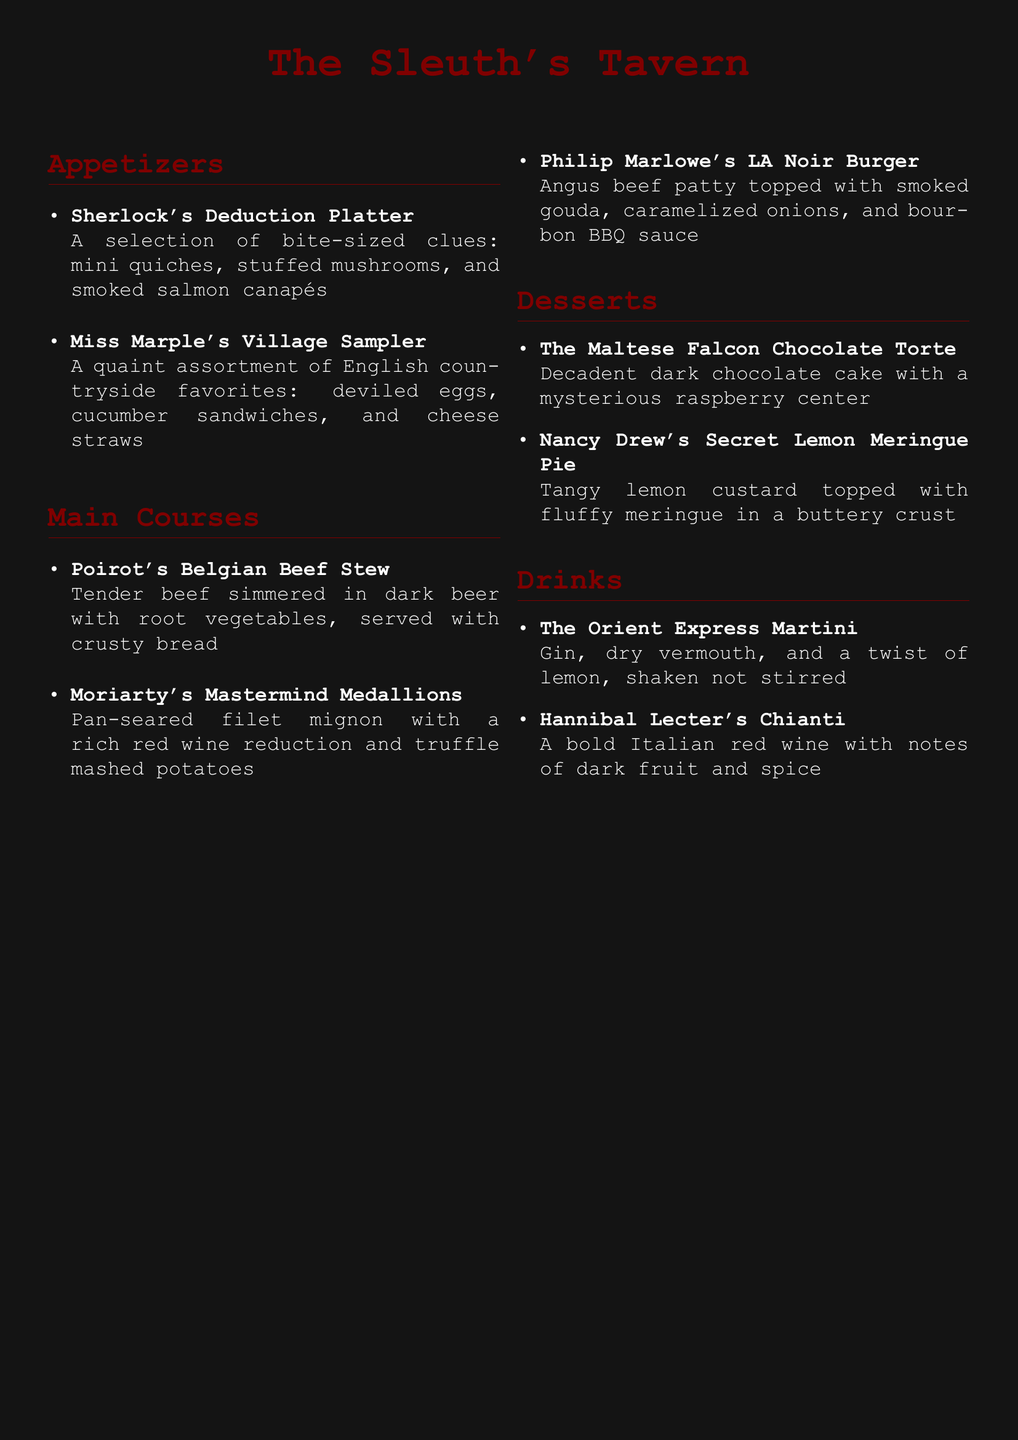What is the name of the appetizer platter? The name of the appetizer platter is found in the Appetizers section, which lists the offerings, including "Sherlock's Deduction Platter."
Answer: Sherlock's Deduction Platter How many main courses are listed on the menu? The total number of main courses can be determined by counting the items in the Main Courses section. There are four items listed.
Answer: 4 What type of burger does Philip Marlowe's dish refer to? The dish refers to a specific style of burger mentioned in the Main Courses section. It is described as an "LA Noir Burger."
Answer: LA Noir Burger What is the primary flavor note of Hannibal Lecter's drink? The primary flavor note of the drink can be found in the Drinks section where it describes the characteristics of Hannibal Lecter's Chianti.
Answer: Dark fruit Which dessert features a chocolate cake? The dessert that features chocolate cake is in the Desserts section, specifically named "The Maltese Falcon Chocolate Torte."
Answer: The Maltese Falcon Chocolate Torte What is the main ingredient in Poirot's dish? The main ingredient in Poirot's Belgian Beef Stew can be found in the description of the dish in the Main Courses section, referring to "tender beef."
Answer: Beef 